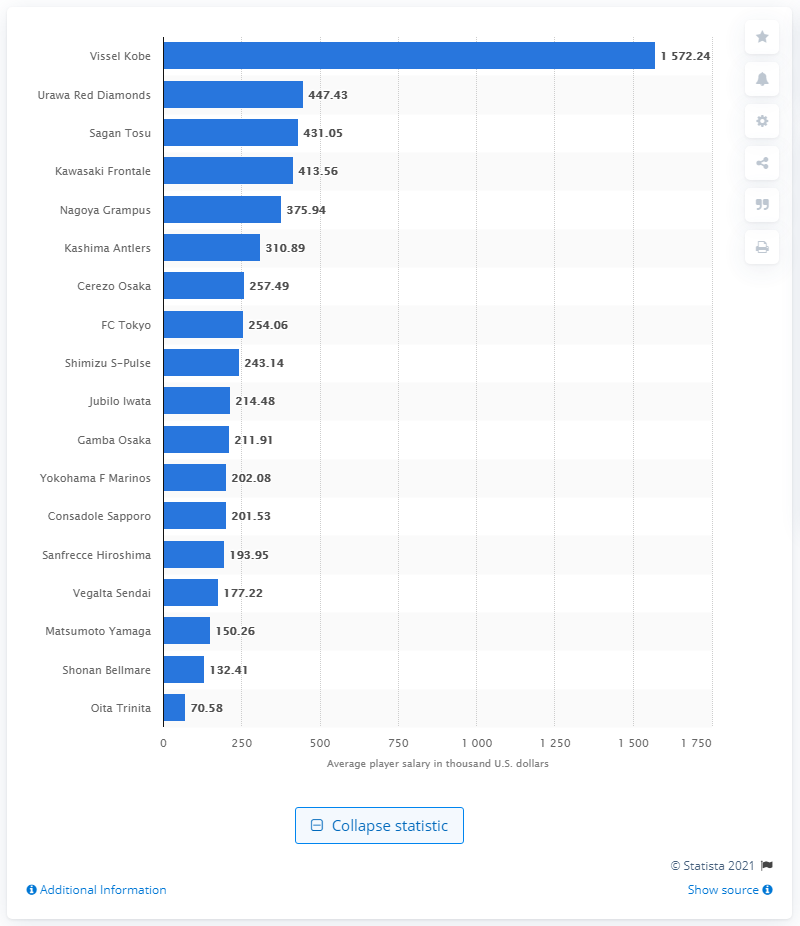Draw attention to some important aspects in this diagram. In the 2019 season, Vissel Kobe was the best-paid team in Japan's first soccer division. 